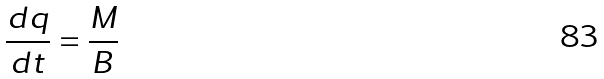Convert formula to latex. <formula><loc_0><loc_0><loc_500><loc_500>\frac { d q } { d t } = \frac { M } { B }</formula> 